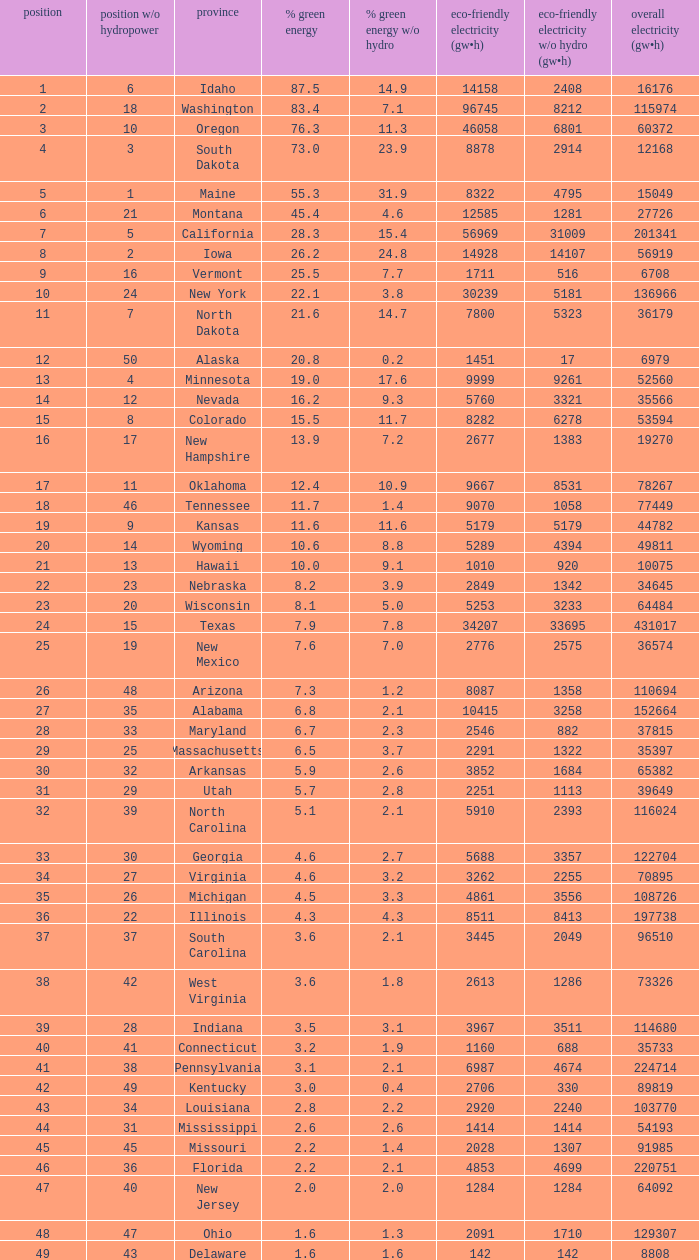What is the percentage of renewable electricity without hydrogen power in the state of South Dakota? 23.9. 